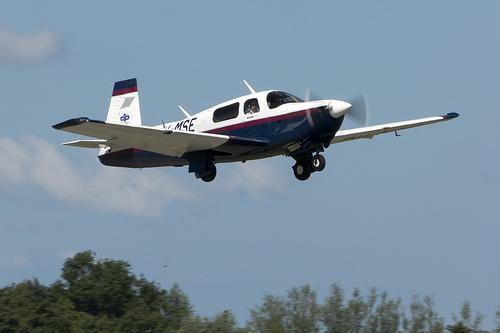How many planes are there?
Give a very brief answer. 1. How many wheels are there?
Give a very brief answer. 3. 